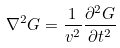Convert formula to latex. <formula><loc_0><loc_0><loc_500><loc_500>\nabla ^ { 2 } G = \frac { 1 } { v ^ { 2 } } \frac { \partial ^ { 2 } G } { \partial t ^ { 2 } }</formula> 